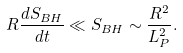<formula> <loc_0><loc_0><loc_500><loc_500>R \frac { d S _ { B H } } { d t } \ll S _ { B H } \sim \frac { R ^ { 2 } } { L _ { P } ^ { 2 } } .</formula> 